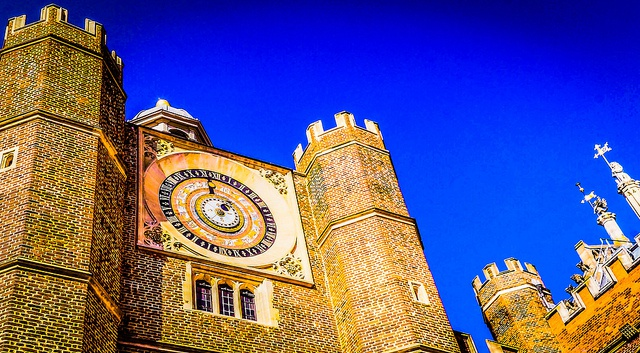Describe the objects in this image and their specific colors. I can see a clock in navy, lightgray, black, and orange tones in this image. 